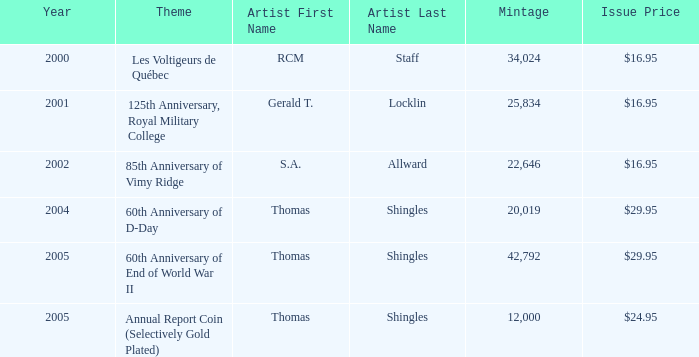What year was S.A. Allward's theme that had an issue price of $16.95 released? 2002.0. 